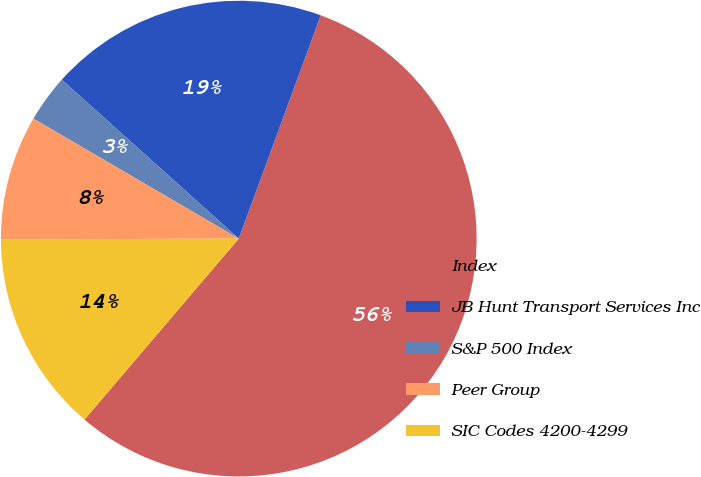Convert chart. <chart><loc_0><loc_0><loc_500><loc_500><pie_chart><fcel>Index<fcel>JB Hunt Transport Services Inc<fcel>S&P 500 Index<fcel>Peer Group<fcel>SIC Codes 4200-4299<nl><fcel>55.63%<fcel>18.95%<fcel>3.23%<fcel>8.47%<fcel>13.71%<nl></chart> 